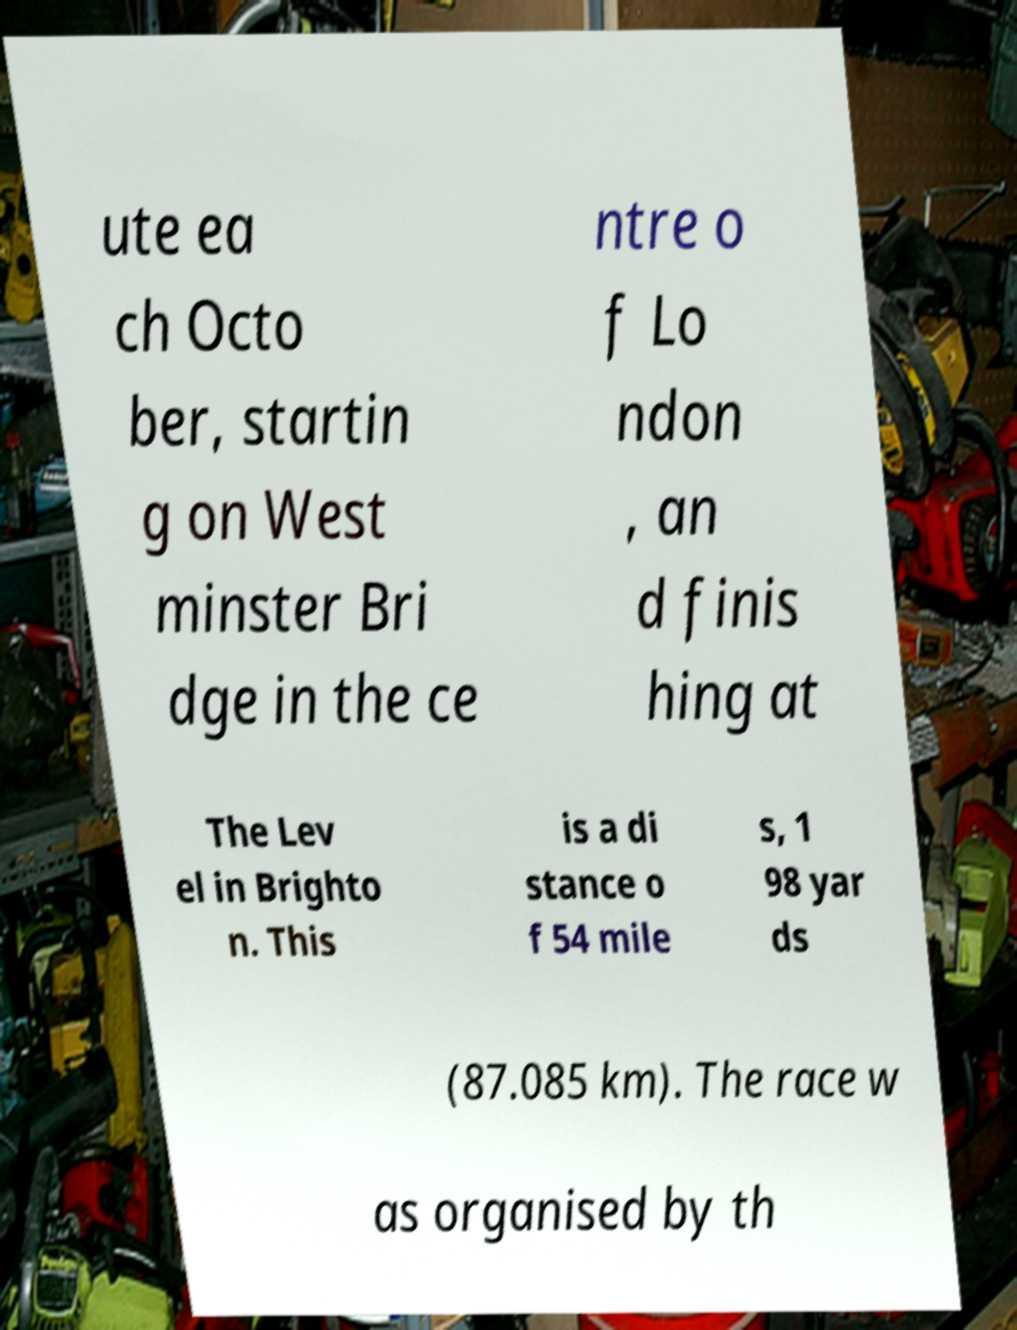Could you assist in decoding the text presented in this image and type it out clearly? ute ea ch Octo ber, startin g on West minster Bri dge in the ce ntre o f Lo ndon , an d finis hing at The Lev el in Brighto n. This is a di stance o f 54 mile s, 1 98 yar ds (87.085 km). The race w as organised by th 